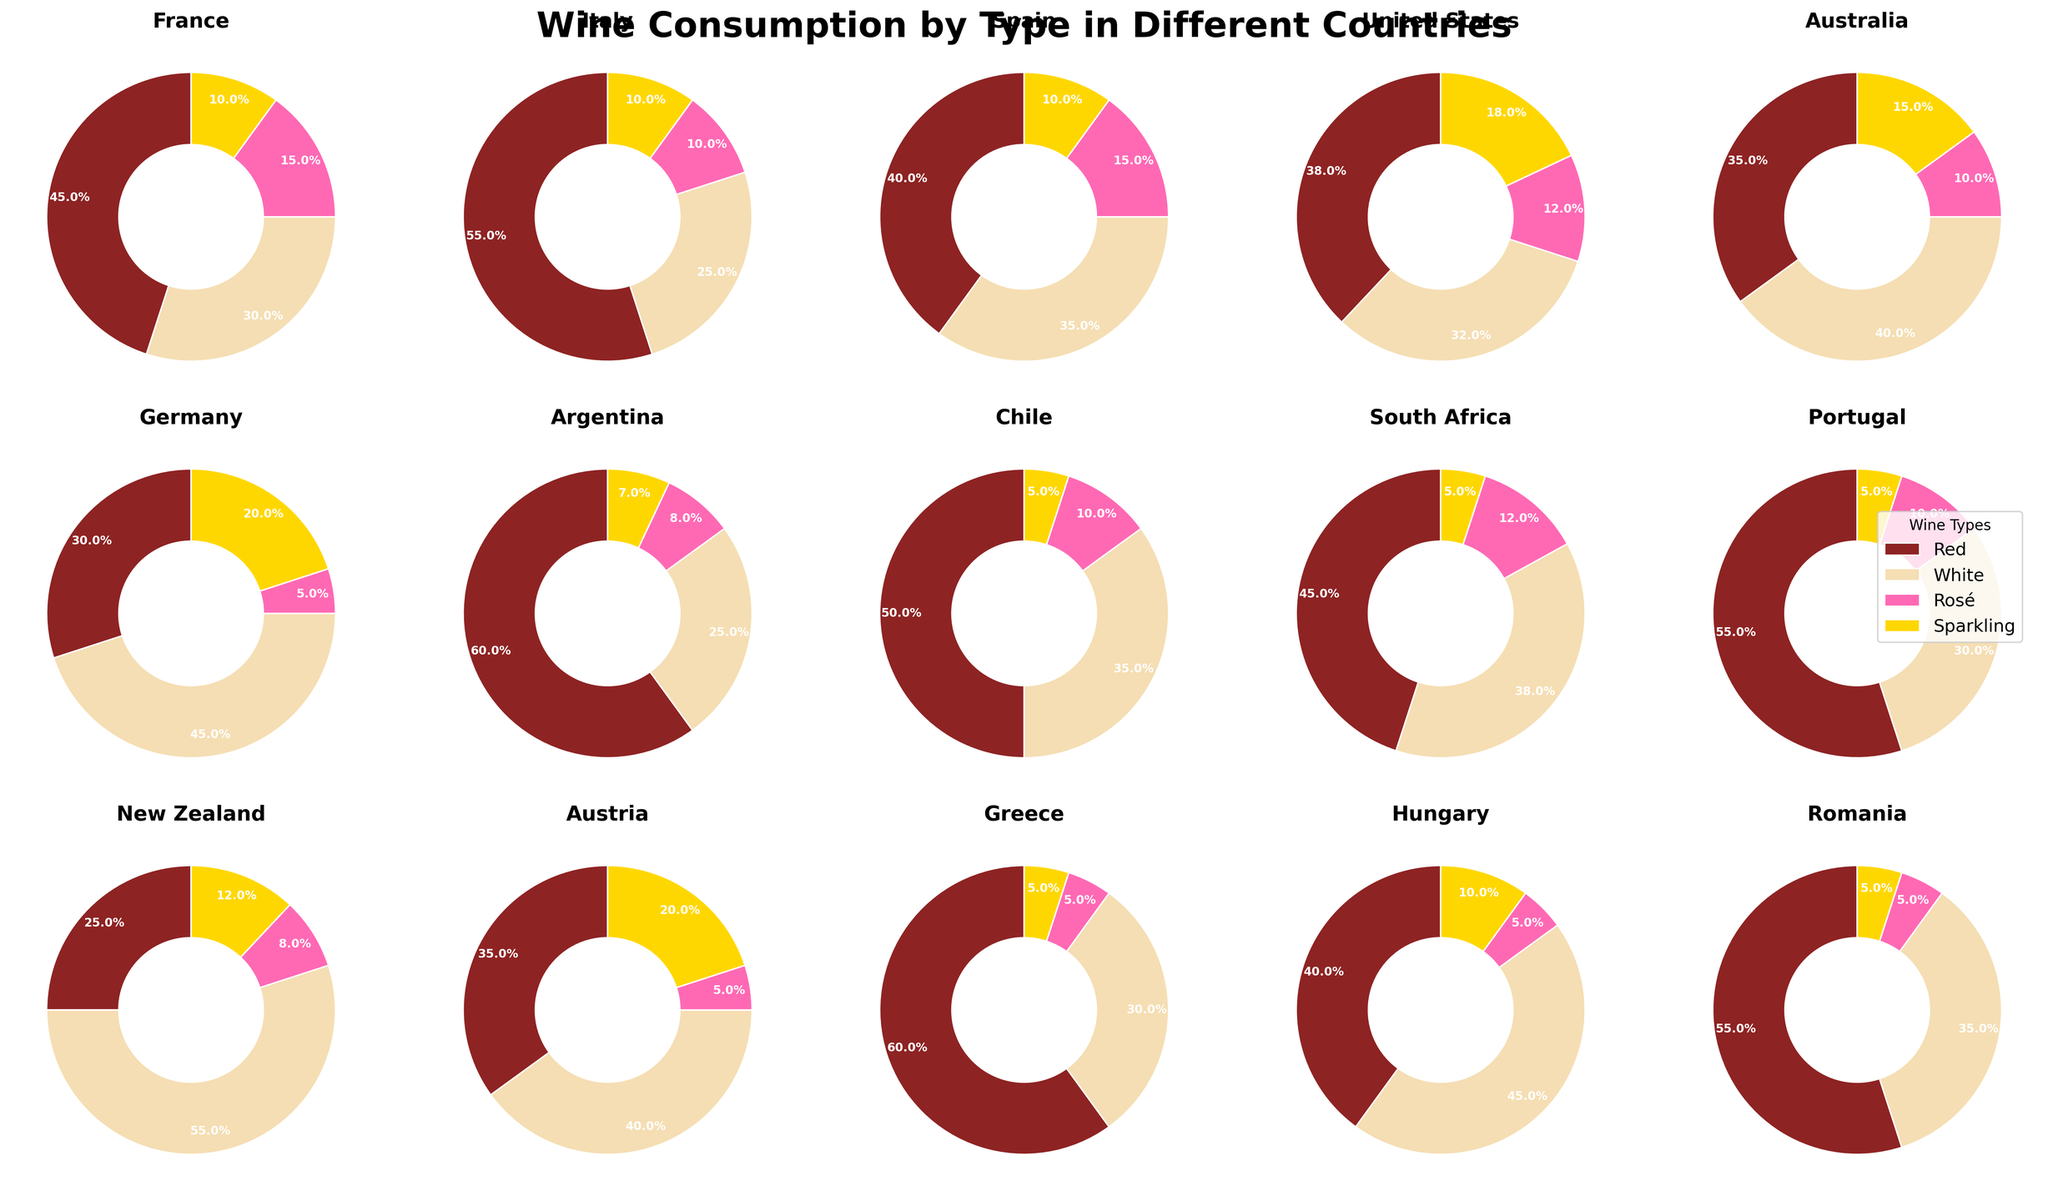what percentage of wine consumption in the United States is sparkling? In the pie chart for the United States, look for the section labeled with the percentage for sparkling wine, which is represented by the golden color.
Answer: 18% Which country has the highest percentage of white wine consumption? Compare the pie charts for each country, focusing on the section representing white wine (wheat color) and identify the highest percentage. New Zealand has the highest percentage for white wine at 55%.
Answer: New Zealand How does the rosé wine consumption in Spain compare to that in France? Observe both Spain and France's pie charts. In Spain, the rosé wine section is 15%, and in France, it is also 15%. Therefore, they are equal.
Answer: Equal What is the total percentage of red wine consumption in Greece and Romania combined? Find the red wine sections in the pie charts for Greece (60%) and Romania (55%). Add these values together: 60 + 55 = 115%.
Answer: 115% Which country has a greater difference between red and white wine consumption, Germany or Australia? Look at the red and white wine sections in the pie charts for Germany and Australia. Germany: Red (30%), White (45%), Difference = 15%. Australia: Red (35%), White (40%), Difference = 5%. Germany has the greater difference of 15%.
Answer: Germany Is rosé wine the least consumed type in Argentina? Check the pie chart for Argentina. Rosé wine is represented by the pink color and has an 8% consumption, which is higher than sparkling wine at 7%, making sparkling wine the least consumed.
Answer: No Which country has the smallest percentage of sparkling wine consumption? Compare the pie charts of all countries for the section representing sparkling wine (golden color). Romania, Chile, and Greece each have the smallest percentage at 5%.
Answer: Romania, Chile, Greece Which country has an equal percentage of red and rosé wine consumption? Look for the red and pink sections in each pie chart to identify if any country has equal percentages for both types. None of the countries have equal percentages of red and rosé wine consumption.
Answer: None Find the average percentage of white wine consumption for France, Spain, and Italy. Locate the white wine sections for France (30%), Spain (35%), and Italy (25%). Sum these values: 30 + 35 + 25 = 90%. Divide by the number of countries: 90 / 3 = 30%.
Answer: 30% Which country has the highest combined percentage of sparkling and rosé wine consumption? Sum the percentages for sparkling and rosé wine sections for each country. For example, France: Sparkling (10%) + Rosé (15%) = 25%. The highest combined value is Germany with Sparkling (20%) + Rosé (5%) = 25%.
Answer: Germany 